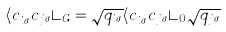Convert formula to latex. <formula><loc_0><loc_0><loc_500><loc_500>\langle c _ { i \sigma } ^ { \dagger } c _ { j \sigma } \rangle _ { G } = \sqrt { q _ { i \sigma } } \langle c _ { i \sigma } ^ { \dagger } c _ { j \sigma } \rangle _ { 0 } \sqrt { q _ { j \sigma } }</formula> 